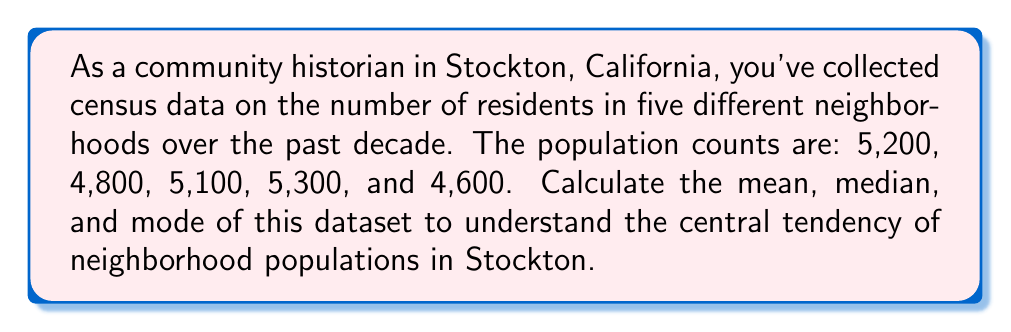Could you help me with this problem? To calculate the measures of central tendency, we'll follow these steps:

1. Mean:
   The mean is the average of all values in the dataset.
   $$\text{Mean} = \frac{\sum_{i=1}^{n} x_i}{n}$$
   where $x_i$ are the individual values and $n$ is the number of values.

   $$\text{Mean} = \frac{5200 + 4800 + 5100 + 5300 + 4600}{5} = \frac{25000}{5} = 5000$$

2. Median:
   To find the median, we first need to arrange the data in ascending order:
   4600, 4800, 5100, 5200, 5300

   Since there are 5 values (odd number), the median is the middle value.
   $$\text{Median} = 5100$$

3. Mode:
   The mode is the value that appears most frequently in the dataset.
   In this case, each value appears only once, so there is no mode.
   We can say that this dataset is multimodal.
Answer: Mean: 5000, Median: 5100, Mode: None (multimodal) 